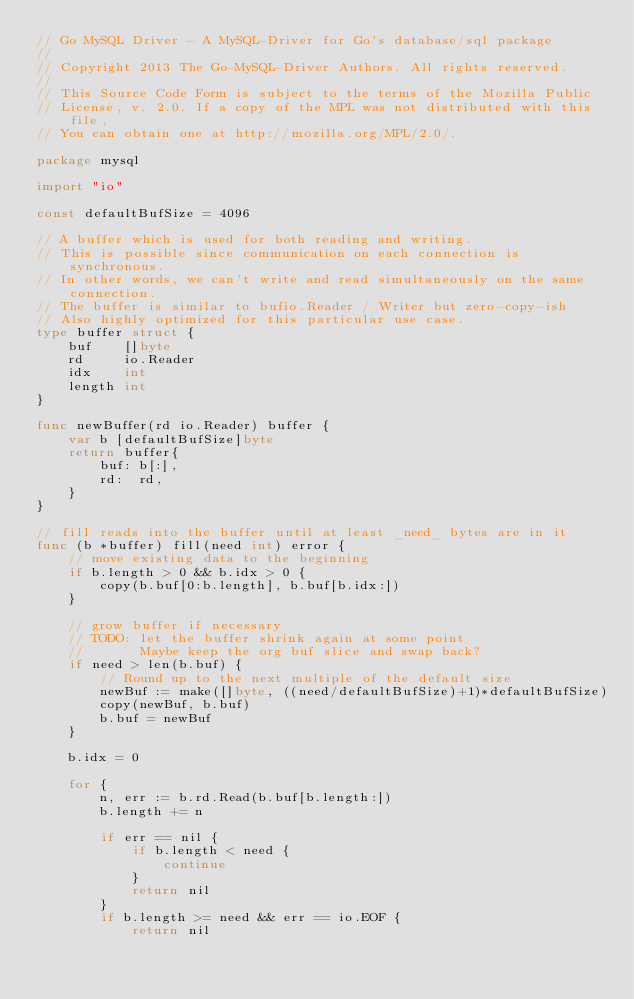<code> <loc_0><loc_0><loc_500><loc_500><_Go_>// Go MySQL Driver - A MySQL-Driver for Go's database/sql package
//
// Copyright 2013 The Go-MySQL-Driver Authors. All rights reserved.
//
// This Source Code Form is subject to the terms of the Mozilla Public
// License, v. 2.0. If a copy of the MPL was not distributed with this file,
// You can obtain one at http://mozilla.org/MPL/2.0/.

package mysql

import "io"

const defaultBufSize = 4096

// A buffer which is used for both reading and writing.
// This is possible since communication on each connection is synchronous.
// In other words, we can't write and read simultaneously on the same connection.
// The buffer is similar to bufio.Reader / Writer but zero-copy-ish
// Also highly optimized for this particular use case.
type buffer struct {
	buf    []byte
	rd     io.Reader
	idx    int
	length int
}

func newBuffer(rd io.Reader) buffer {
	var b [defaultBufSize]byte
	return buffer{
		buf: b[:],
		rd:  rd,
	}
}

// fill reads into the buffer until at least _need_ bytes are in it
func (b *buffer) fill(need int) error {
	// move existing data to the beginning
	if b.length > 0 && b.idx > 0 {
		copy(b.buf[0:b.length], b.buf[b.idx:])
	}

	// grow buffer if necessary
	// TODO: let the buffer shrink again at some point
	//       Maybe keep the org buf slice and swap back?
	if need > len(b.buf) {
		// Round up to the next multiple of the default size
		newBuf := make([]byte, ((need/defaultBufSize)+1)*defaultBufSize)
		copy(newBuf, b.buf)
		b.buf = newBuf
	}

	b.idx = 0

	for {
		n, err := b.rd.Read(b.buf[b.length:])
		b.length += n

		if err == nil {
			if b.length < need {
				continue
			}
			return nil
		}
		if b.length >= need && err == io.EOF {
			return nil</code> 